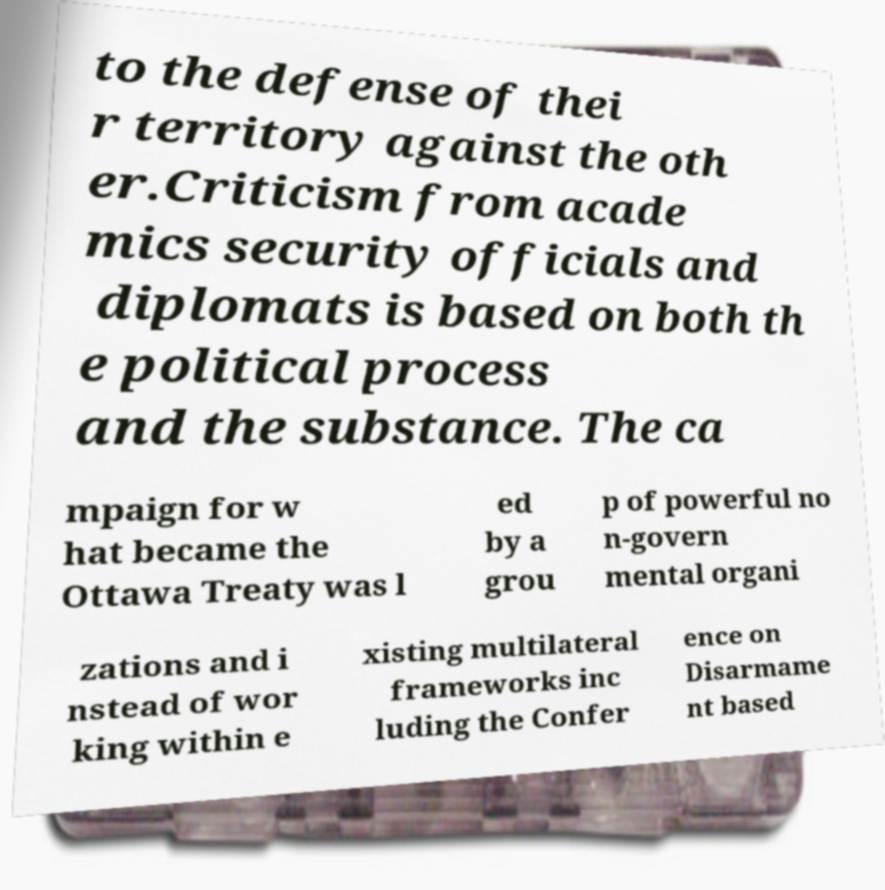Please identify and transcribe the text found in this image. to the defense of thei r territory against the oth er.Criticism from acade mics security officials and diplomats is based on both th e political process and the substance. The ca mpaign for w hat became the Ottawa Treaty was l ed by a grou p of powerful no n-govern mental organi zations and i nstead of wor king within e xisting multilateral frameworks inc luding the Confer ence on Disarmame nt based 